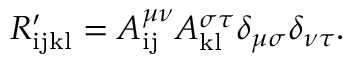<formula> <loc_0><loc_0><loc_500><loc_500>R _ { i j k l } ^ { \prime } = A _ { i j } ^ { \mu \nu } A _ { k l } ^ { \sigma \tau } \delta _ { \mu \sigma } \delta _ { \nu \tau } .</formula> 